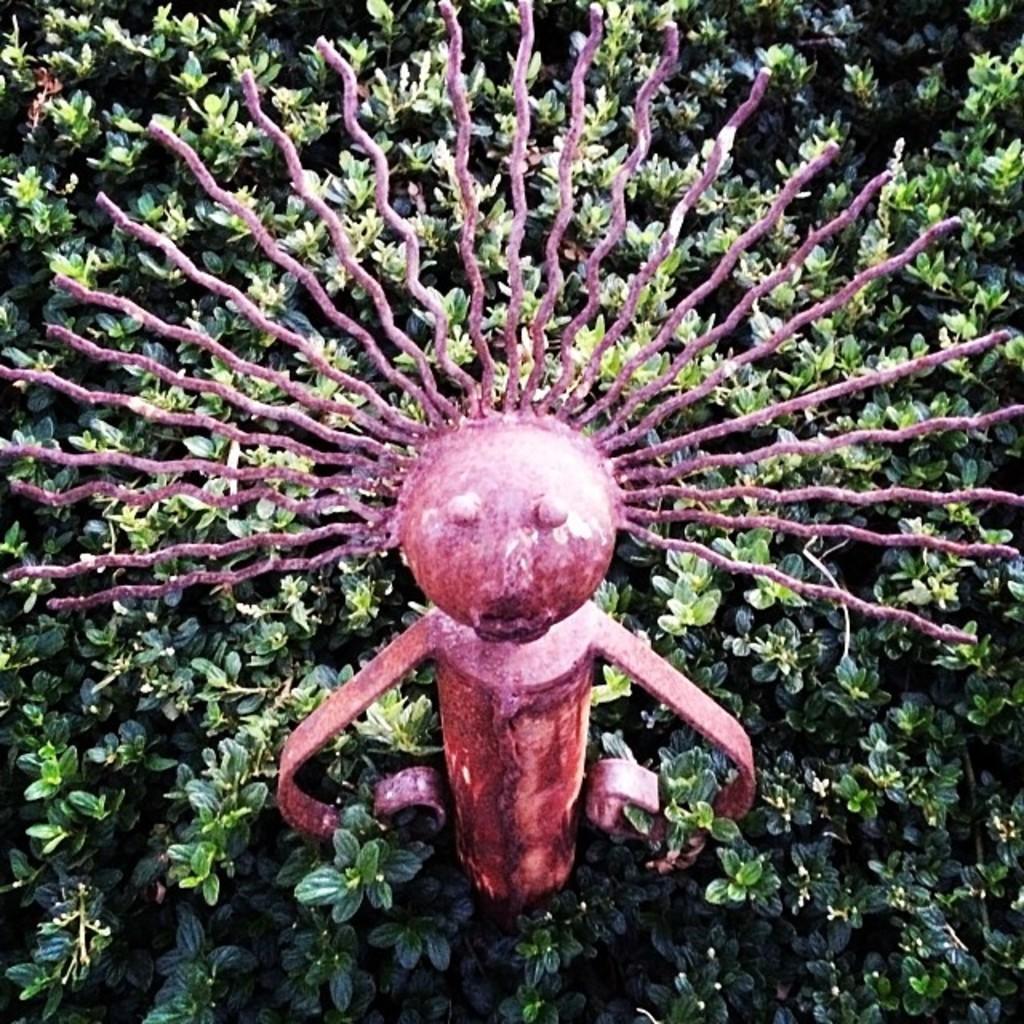How would you summarize this image in a sentence or two? In this picture we can observe a statue. This is made up of iron. We can observe some plants on the ground which are in green color. This iron statue is painted with pink color. 